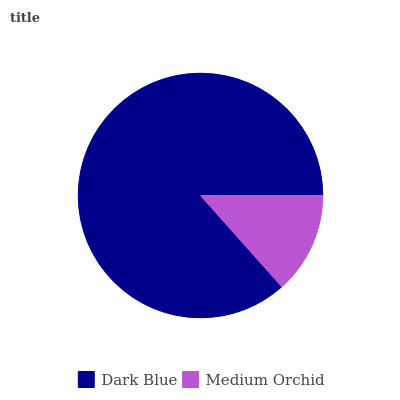Is Medium Orchid the minimum?
Answer yes or no. Yes. Is Dark Blue the maximum?
Answer yes or no. Yes. Is Medium Orchid the maximum?
Answer yes or no. No. Is Dark Blue greater than Medium Orchid?
Answer yes or no. Yes. Is Medium Orchid less than Dark Blue?
Answer yes or no. Yes. Is Medium Orchid greater than Dark Blue?
Answer yes or no. No. Is Dark Blue less than Medium Orchid?
Answer yes or no. No. Is Dark Blue the high median?
Answer yes or no. Yes. Is Medium Orchid the low median?
Answer yes or no. Yes. Is Medium Orchid the high median?
Answer yes or no. No. Is Dark Blue the low median?
Answer yes or no. No. 